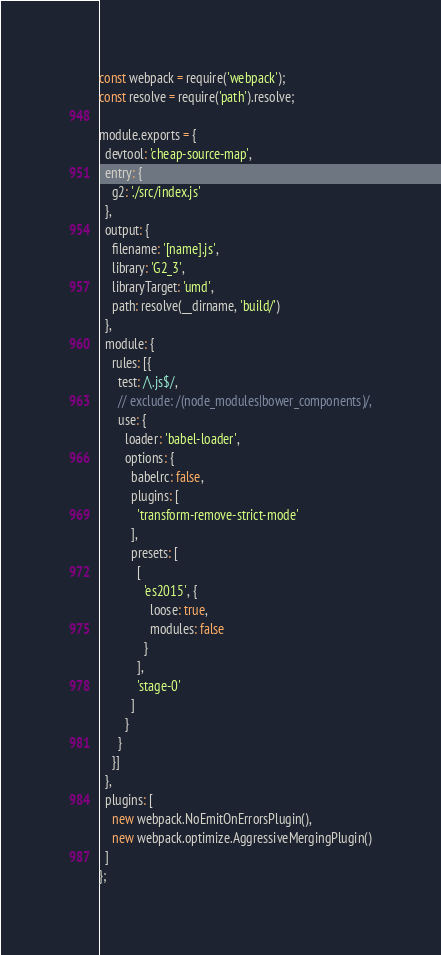Convert code to text. <code><loc_0><loc_0><loc_500><loc_500><_JavaScript_>const webpack = require('webpack');
const resolve = require('path').resolve;

module.exports = {
  devtool: 'cheap-source-map',
  entry: {
    g2: './src/index.js'
  },
  output: {
    filename: '[name].js',
    library: 'G2_3',
    libraryTarget: 'umd',
    path: resolve(__dirname, 'build/')
  },
  module: {
    rules: [{
      test: /\.js$/,
      // exclude: /(node_modules|bower_components)/,
      use: {
        loader: 'babel-loader',
        options: {
          babelrc: false,
          plugins: [
            'transform-remove-strict-mode'
          ],
          presets: [
            [
              'es2015', {
                loose: true,
                modules: false
              }
            ],
            'stage-0'
          ]
        }
      }
    }]
  },
  plugins: [
    new webpack.NoEmitOnErrorsPlugin(),
    new webpack.optimize.AggressiveMergingPlugin()
  ]
};
</code> 